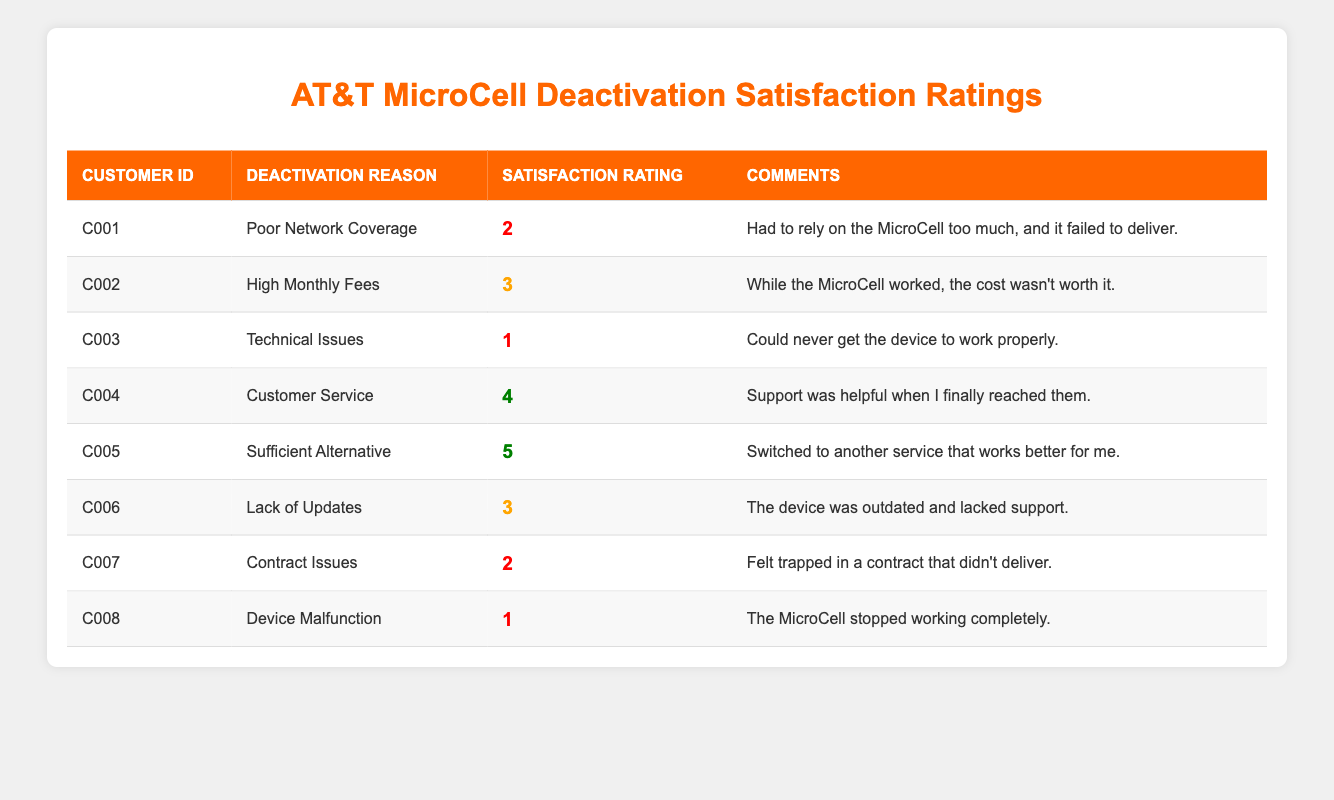What is the satisfaction rating of Customer C003? The satisfaction rating for Customer C003 is located in the table under the Satisfaction Rating column, where it is listed as 1.
Answer: 1 How many customers rated their satisfaction with a score of 4 or higher? Looking at the Satisfaction Rating column, there are two customers (C004 and C005) who rated their satisfaction with scores of 4 and 5 respectively.
Answer: 2 What is the average satisfaction rating of all customers who deactivated their service? To find the average, sum the satisfaction ratings (2 + 3 + 1 + 4 + 5 + 3 + 2 + 1 = 21) and divide by the number of customers (8). The average rating is 21/8 = 2.625.
Answer: 2.625 Did any customer report being satisfied due to effective customer service? Yes, Customer C004 mentioned that support was helpful, which indicates satisfaction attributed to customer service.
Answer: Yes Which deactivation reason had the highest satisfaction rating? Analyzing the table, Customer C005 rated their satisfaction 5 for the reason "Sufficient Alternative," making it the highest.
Answer: Sufficient Alternative How many customers faced technical issues and what was their average satisfaction rating? There is one customer (C003) who faced technical issues with a satisfaction rating of 1. Therefore, the average satisfaction rating for this reason is also 1.
Answer: 1 Is there a customer who experienced device malfunction and rated their satisfaction with a score of 2 or higher? No, Customer C008 rated their satisfaction as 1 for device malfunction.
Answer: No What percentage of customers rated their satisfaction less than 3? There are four customers (C001, C003, C007, and C008) with ratings below 3. To find the percentage: (4/8)*100 = 50%.
Answer: 50% 